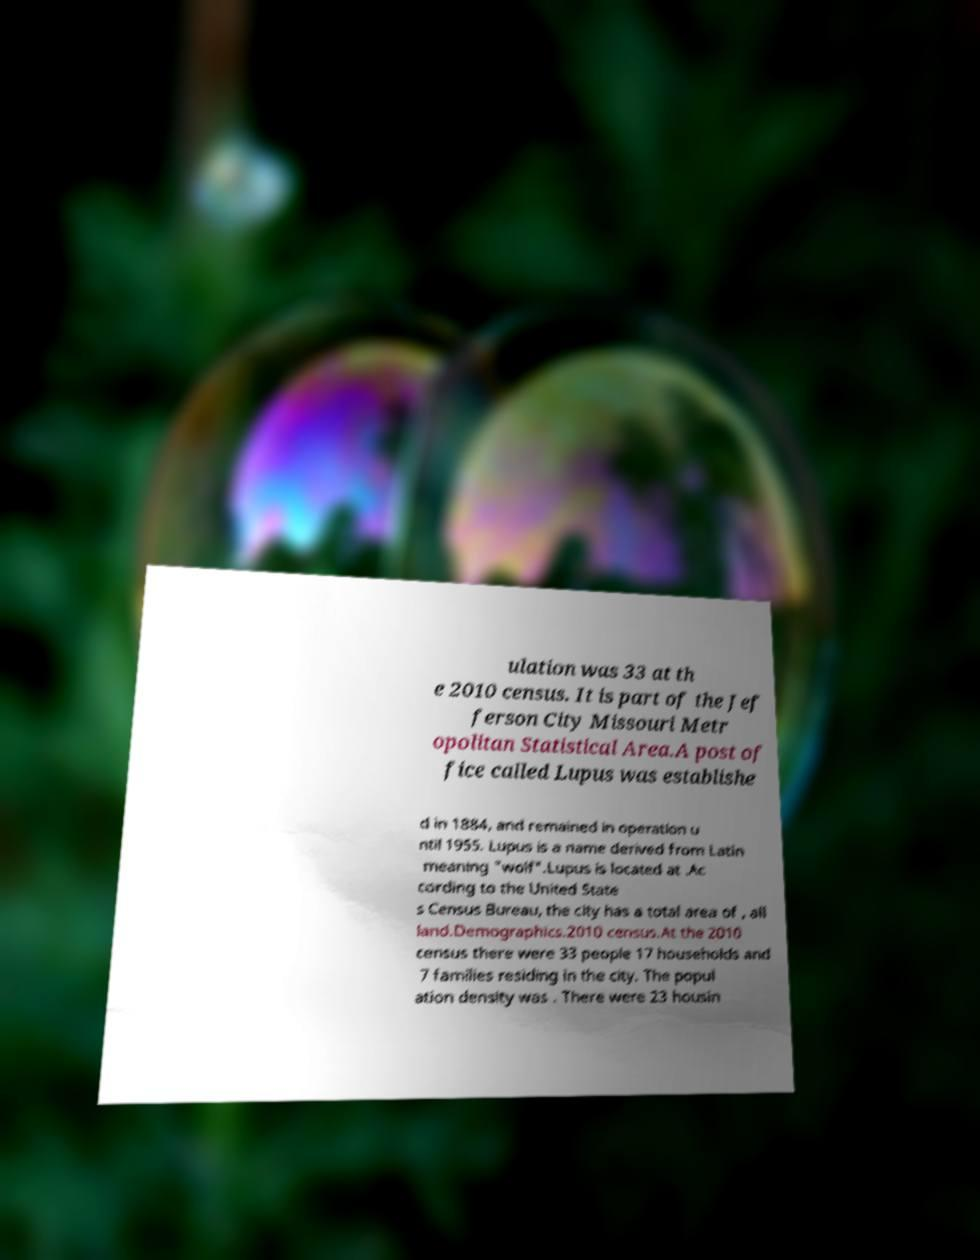Can you read and provide the text displayed in the image?This photo seems to have some interesting text. Can you extract and type it out for me? ulation was 33 at th e 2010 census. It is part of the Jef ferson City Missouri Metr opolitan Statistical Area.A post of fice called Lupus was establishe d in 1884, and remained in operation u ntil 1955. Lupus is a name derived from Latin meaning "wolf".Lupus is located at .Ac cording to the United State s Census Bureau, the city has a total area of , all land.Demographics.2010 census.At the 2010 census there were 33 people 17 households and 7 families residing in the city. The popul ation density was . There were 23 housin 